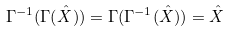Convert formula to latex. <formula><loc_0><loc_0><loc_500><loc_500>\Gamma ^ { - 1 } ( \Gamma ( \hat { X } ) ) = \Gamma ( \Gamma ^ { - 1 } ( \hat { X } ) ) = \hat { X }</formula> 